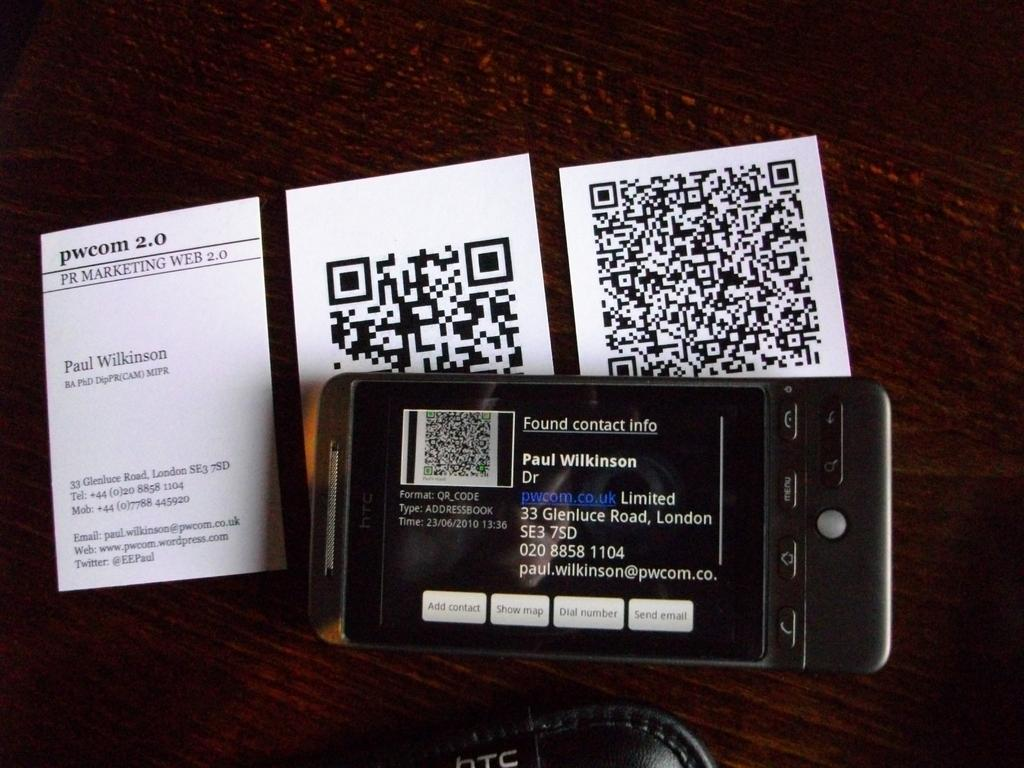<image>
Write a terse but informative summary of the picture. a phone with the name Paul Wilkinson on the screen on top of some QR Codes 